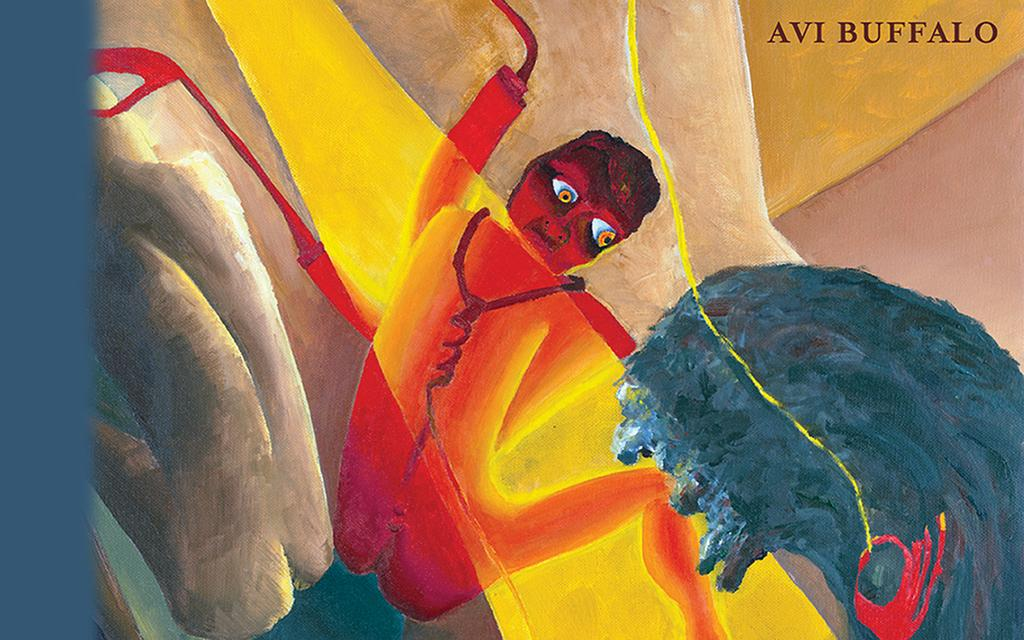What is the main subject of the image? The main subject of the image is a painting. What else can be seen in the image besides the painting? There is some text in the image. What type of yard is visible in the image? There is no yard present in the image. What is the painting's desire in the image? The painting is an inanimate object and does not have desires. 